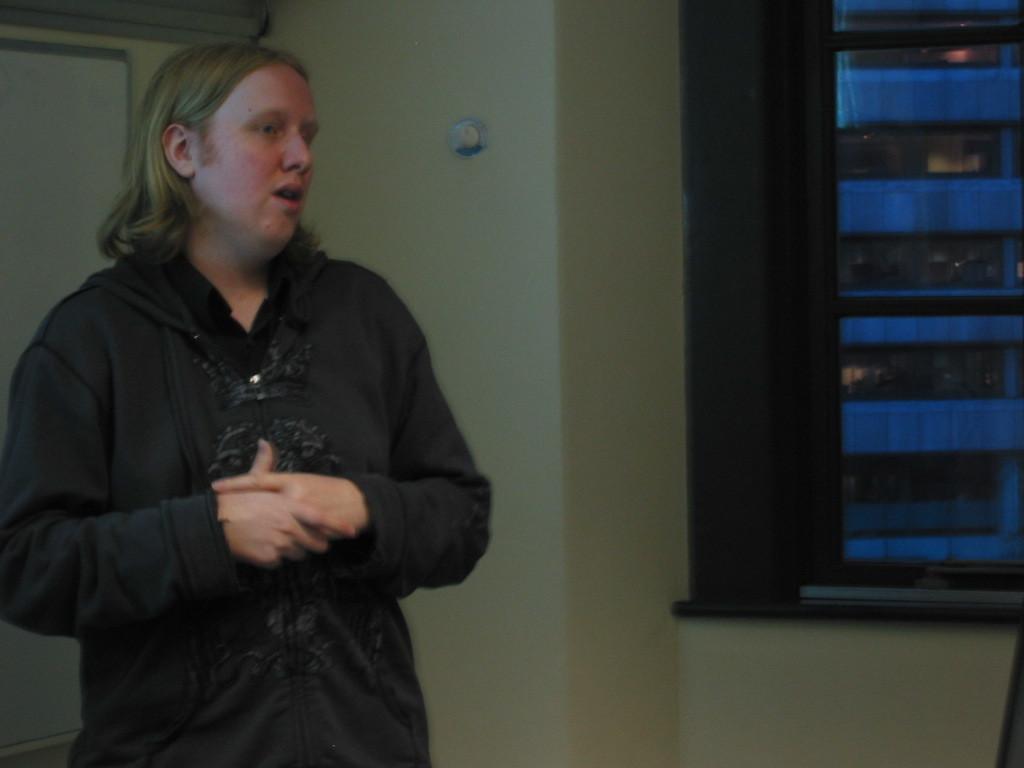Could you give a brief overview of what you see in this image? In this picture I can observe a person on the left side. In the background I can observe wall. 